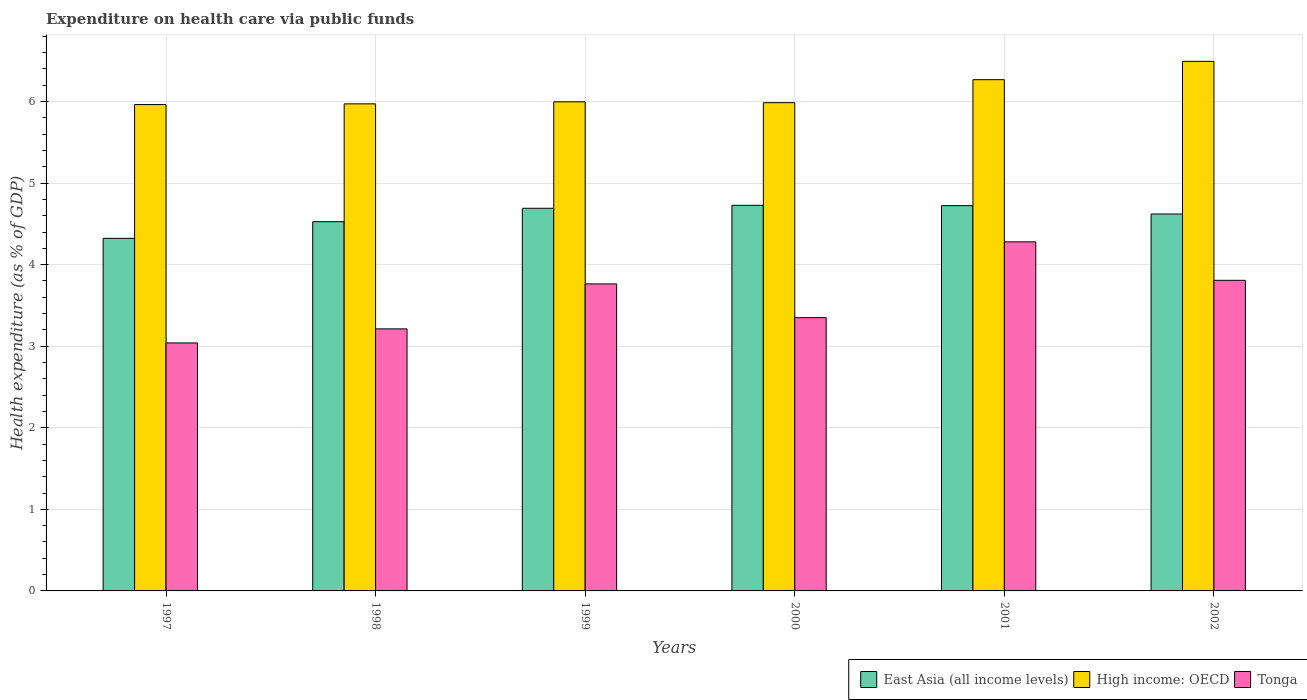How many different coloured bars are there?
Make the answer very short. 3. How many groups of bars are there?
Offer a terse response. 6. Are the number of bars per tick equal to the number of legend labels?
Your answer should be compact. Yes. How many bars are there on the 6th tick from the left?
Give a very brief answer. 3. What is the label of the 3rd group of bars from the left?
Provide a succinct answer. 1999. What is the expenditure made on health care in Tonga in 2000?
Offer a very short reply. 3.35. Across all years, what is the maximum expenditure made on health care in High income: OECD?
Offer a very short reply. 6.49. Across all years, what is the minimum expenditure made on health care in East Asia (all income levels)?
Make the answer very short. 4.32. In which year was the expenditure made on health care in Tonga minimum?
Your answer should be compact. 1997. What is the total expenditure made on health care in East Asia (all income levels) in the graph?
Your answer should be compact. 27.61. What is the difference between the expenditure made on health care in East Asia (all income levels) in 1999 and that in 2002?
Give a very brief answer. 0.07. What is the difference between the expenditure made on health care in Tonga in 2000 and the expenditure made on health care in East Asia (all income levels) in 1999?
Provide a succinct answer. -1.34. What is the average expenditure made on health care in Tonga per year?
Provide a short and direct response. 3.58. In the year 2001, what is the difference between the expenditure made on health care in High income: OECD and expenditure made on health care in East Asia (all income levels)?
Provide a succinct answer. 1.54. What is the ratio of the expenditure made on health care in Tonga in 2000 to that in 2002?
Provide a succinct answer. 0.88. What is the difference between the highest and the second highest expenditure made on health care in East Asia (all income levels)?
Make the answer very short. 0. What is the difference between the highest and the lowest expenditure made on health care in East Asia (all income levels)?
Give a very brief answer. 0.4. In how many years, is the expenditure made on health care in East Asia (all income levels) greater than the average expenditure made on health care in East Asia (all income levels) taken over all years?
Provide a succinct answer. 4. Is the sum of the expenditure made on health care in High income: OECD in 1999 and 2001 greater than the maximum expenditure made on health care in Tonga across all years?
Your answer should be very brief. Yes. What does the 2nd bar from the left in 1999 represents?
Provide a short and direct response. High income: OECD. What does the 2nd bar from the right in 2002 represents?
Offer a terse response. High income: OECD. Is it the case that in every year, the sum of the expenditure made on health care in Tonga and expenditure made on health care in High income: OECD is greater than the expenditure made on health care in East Asia (all income levels)?
Your answer should be compact. Yes. Does the graph contain any zero values?
Offer a very short reply. No. Does the graph contain grids?
Your response must be concise. Yes. Where does the legend appear in the graph?
Ensure brevity in your answer.  Bottom right. How many legend labels are there?
Offer a very short reply. 3. How are the legend labels stacked?
Your response must be concise. Horizontal. What is the title of the graph?
Your answer should be compact. Expenditure on health care via public funds. What is the label or title of the Y-axis?
Your answer should be compact. Health expenditure (as % of GDP). What is the Health expenditure (as % of GDP) of East Asia (all income levels) in 1997?
Your response must be concise. 4.32. What is the Health expenditure (as % of GDP) of High income: OECD in 1997?
Make the answer very short. 5.96. What is the Health expenditure (as % of GDP) of Tonga in 1997?
Ensure brevity in your answer.  3.04. What is the Health expenditure (as % of GDP) in East Asia (all income levels) in 1998?
Offer a terse response. 4.53. What is the Health expenditure (as % of GDP) in High income: OECD in 1998?
Give a very brief answer. 5.97. What is the Health expenditure (as % of GDP) of Tonga in 1998?
Ensure brevity in your answer.  3.21. What is the Health expenditure (as % of GDP) of East Asia (all income levels) in 1999?
Your answer should be compact. 4.69. What is the Health expenditure (as % of GDP) in High income: OECD in 1999?
Your response must be concise. 6. What is the Health expenditure (as % of GDP) of Tonga in 1999?
Offer a very short reply. 3.76. What is the Health expenditure (as % of GDP) of East Asia (all income levels) in 2000?
Offer a terse response. 4.73. What is the Health expenditure (as % of GDP) of High income: OECD in 2000?
Keep it short and to the point. 5.99. What is the Health expenditure (as % of GDP) of Tonga in 2000?
Keep it short and to the point. 3.35. What is the Health expenditure (as % of GDP) in East Asia (all income levels) in 2001?
Keep it short and to the point. 4.72. What is the Health expenditure (as % of GDP) of High income: OECD in 2001?
Your answer should be very brief. 6.27. What is the Health expenditure (as % of GDP) of Tonga in 2001?
Your response must be concise. 4.28. What is the Health expenditure (as % of GDP) of East Asia (all income levels) in 2002?
Keep it short and to the point. 4.62. What is the Health expenditure (as % of GDP) of High income: OECD in 2002?
Provide a succinct answer. 6.49. What is the Health expenditure (as % of GDP) in Tonga in 2002?
Keep it short and to the point. 3.81. Across all years, what is the maximum Health expenditure (as % of GDP) of East Asia (all income levels)?
Offer a very short reply. 4.73. Across all years, what is the maximum Health expenditure (as % of GDP) of High income: OECD?
Provide a short and direct response. 6.49. Across all years, what is the maximum Health expenditure (as % of GDP) of Tonga?
Offer a terse response. 4.28. Across all years, what is the minimum Health expenditure (as % of GDP) in East Asia (all income levels)?
Make the answer very short. 4.32. Across all years, what is the minimum Health expenditure (as % of GDP) in High income: OECD?
Your response must be concise. 5.96. Across all years, what is the minimum Health expenditure (as % of GDP) in Tonga?
Keep it short and to the point. 3.04. What is the total Health expenditure (as % of GDP) in East Asia (all income levels) in the graph?
Your answer should be very brief. 27.61. What is the total Health expenditure (as % of GDP) in High income: OECD in the graph?
Provide a short and direct response. 36.68. What is the total Health expenditure (as % of GDP) in Tonga in the graph?
Make the answer very short. 21.45. What is the difference between the Health expenditure (as % of GDP) of East Asia (all income levels) in 1997 and that in 1998?
Make the answer very short. -0.2. What is the difference between the Health expenditure (as % of GDP) of High income: OECD in 1997 and that in 1998?
Make the answer very short. -0.01. What is the difference between the Health expenditure (as % of GDP) of Tonga in 1997 and that in 1998?
Make the answer very short. -0.17. What is the difference between the Health expenditure (as % of GDP) of East Asia (all income levels) in 1997 and that in 1999?
Keep it short and to the point. -0.37. What is the difference between the Health expenditure (as % of GDP) in High income: OECD in 1997 and that in 1999?
Your response must be concise. -0.03. What is the difference between the Health expenditure (as % of GDP) in Tonga in 1997 and that in 1999?
Provide a succinct answer. -0.72. What is the difference between the Health expenditure (as % of GDP) in East Asia (all income levels) in 1997 and that in 2000?
Your response must be concise. -0.4. What is the difference between the Health expenditure (as % of GDP) of High income: OECD in 1997 and that in 2000?
Your answer should be very brief. -0.02. What is the difference between the Health expenditure (as % of GDP) of Tonga in 1997 and that in 2000?
Give a very brief answer. -0.31. What is the difference between the Health expenditure (as % of GDP) of East Asia (all income levels) in 1997 and that in 2001?
Your response must be concise. -0.4. What is the difference between the Health expenditure (as % of GDP) in High income: OECD in 1997 and that in 2001?
Give a very brief answer. -0.3. What is the difference between the Health expenditure (as % of GDP) in Tonga in 1997 and that in 2001?
Your answer should be very brief. -1.24. What is the difference between the Health expenditure (as % of GDP) of East Asia (all income levels) in 1997 and that in 2002?
Give a very brief answer. -0.3. What is the difference between the Health expenditure (as % of GDP) of High income: OECD in 1997 and that in 2002?
Your response must be concise. -0.53. What is the difference between the Health expenditure (as % of GDP) of Tonga in 1997 and that in 2002?
Provide a short and direct response. -0.77. What is the difference between the Health expenditure (as % of GDP) in East Asia (all income levels) in 1998 and that in 1999?
Offer a very short reply. -0.16. What is the difference between the Health expenditure (as % of GDP) in High income: OECD in 1998 and that in 1999?
Your answer should be compact. -0.02. What is the difference between the Health expenditure (as % of GDP) of Tonga in 1998 and that in 1999?
Your answer should be compact. -0.55. What is the difference between the Health expenditure (as % of GDP) of East Asia (all income levels) in 1998 and that in 2000?
Your answer should be very brief. -0.2. What is the difference between the Health expenditure (as % of GDP) of High income: OECD in 1998 and that in 2000?
Keep it short and to the point. -0.01. What is the difference between the Health expenditure (as % of GDP) in Tonga in 1998 and that in 2000?
Your answer should be very brief. -0.14. What is the difference between the Health expenditure (as % of GDP) of East Asia (all income levels) in 1998 and that in 2001?
Offer a terse response. -0.2. What is the difference between the Health expenditure (as % of GDP) of High income: OECD in 1998 and that in 2001?
Offer a very short reply. -0.3. What is the difference between the Health expenditure (as % of GDP) of Tonga in 1998 and that in 2001?
Provide a succinct answer. -1.07. What is the difference between the Health expenditure (as % of GDP) of East Asia (all income levels) in 1998 and that in 2002?
Make the answer very short. -0.09. What is the difference between the Health expenditure (as % of GDP) in High income: OECD in 1998 and that in 2002?
Offer a terse response. -0.52. What is the difference between the Health expenditure (as % of GDP) of Tonga in 1998 and that in 2002?
Keep it short and to the point. -0.6. What is the difference between the Health expenditure (as % of GDP) in East Asia (all income levels) in 1999 and that in 2000?
Provide a short and direct response. -0.04. What is the difference between the Health expenditure (as % of GDP) of High income: OECD in 1999 and that in 2000?
Provide a short and direct response. 0.01. What is the difference between the Health expenditure (as % of GDP) in Tonga in 1999 and that in 2000?
Make the answer very short. 0.41. What is the difference between the Health expenditure (as % of GDP) in East Asia (all income levels) in 1999 and that in 2001?
Your answer should be compact. -0.03. What is the difference between the Health expenditure (as % of GDP) in High income: OECD in 1999 and that in 2001?
Offer a very short reply. -0.27. What is the difference between the Health expenditure (as % of GDP) in Tonga in 1999 and that in 2001?
Ensure brevity in your answer.  -0.52. What is the difference between the Health expenditure (as % of GDP) in East Asia (all income levels) in 1999 and that in 2002?
Your answer should be very brief. 0.07. What is the difference between the Health expenditure (as % of GDP) of High income: OECD in 1999 and that in 2002?
Your answer should be very brief. -0.5. What is the difference between the Health expenditure (as % of GDP) in Tonga in 1999 and that in 2002?
Your response must be concise. -0.04. What is the difference between the Health expenditure (as % of GDP) of East Asia (all income levels) in 2000 and that in 2001?
Your answer should be very brief. 0. What is the difference between the Health expenditure (as % of GDP) of High income: OECD in 2000 and that in 2001?
Provide a succinct answer. -0.28. What is the difference between the Health expenditure (as % of GDP) in Tonga in 2000 and that in 2001?
Your answer should be compact. -0.93. What is the difference between the Health expenditure (as % of GDP) of East Asia (all income levels) in 2000 and that in 2002?
Your answer should be compact. 0.11. What is the difference between the Health expenditure (as % of GDP) in High income: OECD in 2000 and that in 2002?
Provide a succinct answer. -0.51. What is the difference between the Health expenditure (as % of GDP) in Tonga in 2000 and that in 2002?
Your response must be concise. -0.46. What is the difference between the Health expenditure (as % of GDP) in East Asia (all income levels) in 2001 and that in 2002?
Ensure brevity in your answer.  0.1. What is the difference between the Health expenditure (as % of GDP) of High income: OECD in 2001 and that in 2002?
Your answer should be very brief. -0.22. What is the difference between the Health expenditure (as % of GDP) in Tonga in 2001 and that in 2002?
Your answer should be compact. 0.47. What is the difference between the Health expenditure (as % of GDP) of East Asia (all income levels) in 1997 and the Health expenditure (as % of GDP) of High income: OECD in 1998?
Offer a very short reply. -1.65. What is the difference between the Health expenditure (as % of GDP) in East Asia (all income levels) in 1997 and the Health expenditure (as % of GDP) in Tonga in 1998?
Your response must be concise. 1.11. What is the difference between the Health expenditure (as % of GDP) in High income: OECD in 1997 and the Health expenditure (as % of GDP) in Tonga in 1998?
Make the answer very short. 2.75. What is the difference between the Health expenditure (as % of GDP) of East Asia (all income levels) in 1997 and the Health expenditure (as % of GDP) of High income: OECD in 1999?
Keep it short and to the point. -1.67. What is the difference between the Health expenditure (as % of GDP) in East Asia (all income levels) in 1997 and the Health expenditure (as % of GDP) in Tonga in 1999?
Keep it short and to the point. 0.56. What is the difference between the Health expenditure (as % of GDP) of High income: OECD in 1997 and the Health expenditure (as % of GDP) of Tonga in 1999?
Provide a short and direct response. 2.2. What is the difference between the Health expenditure (as % of GDP) of East Asia (all income levels) in 1997 and the Health expenditure (as % of GDP) of High income: OECD in 2000?
Your answer should be compact. -1.66. What is the difference between the Health expenditure (as % of GDP) in East Asia (all income levels) in 1997 and the Health expenditure (as % of GDP) in Tonga in 2000?
Offer a very short reply. 0.97. What is the difference between the Health expenditure (as % of GDP) of High income: OECD in 1997 and the Health expenditure (as % of GDP) of Tonga in 2000?
Provide a short and direct response. 2.61. What is the difference between the Health expenditure (as % of GDP) of East Asia (all income levels) in 1997 and the Health expenditure (as % of GDP) of High income: OECD in 2001?
Keep it short and to the point. -1.95. What is the difference between the Health expenditure (as % of GDP) in East Asia (all income levels) in 1997 and the Health expenditure (as % of GDP) in Tonga in 2001?
Provide a succinct answer. 0.04. What is the difference between the Health expenditure (as % of GDP) of High income: OECD in 1997 and the Health expenditure (as % of GDP) of Tonga in 2001?
Ensure brevity in your answer.  1.68. What is the difference between the Health expenditure (as % of GDP) of East Asia (all income levels) in 1997 and the Health expenditure (as % of GDP) of High income: OECD in 2002?
Your answer should be compact. -2.17. What is the difference between the Health expenditure (as % of GDP) in East Asia (all income levels) in 1997 and the Health expenditure (as % of GDP) in Tonga in 2002?
Ensure brevity in your answer.  0.51. What is the difference between the Health expenditure (as % of GDP) of High income: OECD in 1997 and the Health expenditure (as % of GDP) of Tonga in 2002?
Your response must be concise. 2.15. What is the difference between the Health expenditure (as % of GDP) in East Asia (all income levels) in 1998 and the Health expenditure (as % of GDP) in High income: OECD in 1999?
Provide a succinct answer. -1.47. What is the difference between the Health expenditure (as % of GDP) in East Asia (all income levels) in 1998 and the Health expenditure (as % of GDP) in Tonga in 1999?
Your response must be concise. 0.76. What is the difference between the Health expenditure (as % of GDP) in High income: OECD in 1998 and the Health expenditure (as % of GDP) in Tonga in 1999?
Your answer should be very brief. 2.21. What is the difference between the Health expenditure (as % of GDP) in East Asia (all income levels) in 1998 and the Health expenditure (as % of GDP) in High income: OECD in 2000?
Offer a very short reply. -1.46. What is the difference between the Health expenditure (as % of GDP) of East Asia (all income levels) in 1998 and the Health expenditure (as % of GDP) of Tonga in 2000?
Provide a succinct answer. 1.18. What is the difference between the Health expenditure (as % of GDP) in High income: OECD in 1998 and the Health expenditure (as % of GDP) in Tonga in 2000?
Give a very brief answer. 2.62. What is the difference between the Health expenditure (as % of GDP) of East Asia (all income levels) in 1998 and the Health expenditure (as % of GDP) of High income: OECD in 2001?
Offer a very short reply. -1.74. What is the difference between the Health expenditure (as % of GDP) in East Asia (all income levels) in 1998 and the Health expenditure (as % of GDP) in Tonga in 2001?
Give a very brief answer. 0.25. What is the difference between the Health expenditure (as % of GDP) of High income: OECD in 1998 and the Health expenditure (as % of GDP) of Tonga in 2001?
Your answer should be very brief. 1.69. What is the difference between the Health expenditure (as % of GDP) of East Asia (all income levels) in 1998 and the Health expenditure (as % of GDP) of High income: OECD in 2002?
Ensure brevity in your answer.  -1.97. What is the difference between the Health expenditure (as % of GDP) of East Asia (all income levels) in 1998 and the Health expenditure (as % of GDP) of Tonga in 2002?
Offer a very short reply. 0.72. What is the difference between the Health expenditure (as % of GDP) of High income: OECD in 1998 and the Health expenditure (as % of GDP) of Tonga in 2002?
Ensure brevity in your answer.  2.16. What is the difference between the Health expenditure (as % of GDP) of East Asia (all income levels) in 1999 and the Health expenditure (as % of GDP) of High income: OECD in 2000?
Make the answer very short. -1.29. What is the difference between the Health expenditure (as % of GDP) in East Asia (all income levels) in 1999 and the Health expenditure (as % of GDP) in Tonga in 2000?
Give a very brief answer. 1.34. What is the difference between the Health expenditure (as % of GDP) in High income: OECD in 1999 and the Health expenditure (as % of GDP) in Tonga in 2000?
Provide a short and direct response. 2.65. What is the difference between the Health expenditure (as % of GDP) in East Asia (all income levels) in 1999 and the Health expenditure (as % of GDP) in High income: OECD in 2001?
Provide a short and direct response. -1.58. What is the difference between the Health expenditure (as % of GDP) in East Asia (all income levels) in 1999 and the Health expenditure (as % of GDP) in Tonga in 2001?
Provide a succinct answer. 0.41. What is the difference between the Health expenditure (as % of GDP) of High income: OECD in 1999 and the Health expenditure (as % of GDP) of Tonga in 2001?
Provide a short and direct response. 1.72. What is the difference between the Health expenditure (as % of GDP) of East Asia (all income levels) in 1999 and the Health expenditure (as % of GDP) of High income: OECD in 2002?
Your answer should be very brief. -1.8. What is the difference between the Health expenditure (as % of GDP) of East Asia (all income levels) in 1999 and the Health expenditure (as % of GDP) of Tonga in 2002?
Make the answer very short. 0.88. What is the difference between the Health expenditure (as % of GDP) of High income: OECD in 1999 and the Health expenditure (as % of GDP) of Tonga in 2002?
Ensure brevity in your answer.  2.19. What is the difference between the Health expenditure (as % of GDP) of East Asia (all income levels) in 2000 and the Health expenditure (as % of GDP) of High income: OECD in 2001?
Provide a short and direct response. -1.54. What is the difference between the Health expenditure (as % of GDP) in East Asia (all income levels) in 2000 and the Health expenditure (as % of GDP) in Tonga in 2001?
Ensure brevity in your answer.  0.45. What is the difference between the Health expenditure (as % of GDP) of High income: OECD in 2000 and the Health expenditure (as % of GDP) of Tonga in 2001?
Ensure brevity in your answer.  1.71. What is the difference between the Health expenditure (as % of GDP) of East Asia (all income levels) in 2000 and the Health expenditure (as % of GDP) of High income: OECD in 2002?
Make the answer very short. -1.76. What is the difference between the Health expenditure (as % of GDP) in East Asia (all income levels) in 2000 and the Health expenditure (as % of GDP) in Tonga in 2002?
Your answer should be very brief. 0.92. What is the difference between the Health expenditure (as % of GDP) in High income: OECD in 2000 and the Health expenditure (as % of GDP) in Tonga in 2002?
Offer a terse response. 2.18. What is the difference between the Health expenditure (as % of GDP) in East Asia (all income levels) in 2001 and the Health expenditure (as % of GDP) in High income: OECD in 2002?
Ensure brevity in your answer.  -1.77. What is the difference between the Health expenditure (as % of GDP) in East Asia (all income levels) in 2001 and the Health expenditure (as % of GDP) in Tonga in 2002?
Provide a short and direct response. 0.92. What is the difference between the Health expenditure (as % of GDP) of High income: OECD in 2001 and the Health expenditure (as % of GDP) of Tonga in 2002?
Give a very brief answer. 2.46. What is the average Health expenditure (as % of GDP) in East Asia (all income levels) per year?
Provide a succinct answer. 4.6. What is the average Health expenditure (as % of GDP) in High income: OECD per year?
Ensure brevity in your answer.  6.11. What is the average Health expenditure (as % of GDP) in Tonga per year?
Make the answer very short. 3.58. In the year 1997, what is the difference between the Health expenditure (as % of GDP) in East Asia (all income levels) and Health expenditure (as % of GDP) in High income: OECD?
Make the answer very short. -1.64. In the year 1997, what is the difference between the Health expenditure (as % of GDP) of East Asia (all income levels) and Health expenditure (as % of GDP) of Tonga?
Provide a succinct answer. 1.28. In the year 1997, what is the difference between the Health expenditure (as % of GDP) of High income: OECD and Health expenditure (as % of GDP) of Tonga?
Provide a succinct answer. 2.92. In the year 1998, what is the difference between the Health expenditure (as % of GDP) in East Asia (all income levels) and Health expenditure (as % of GDP) in High income: OECD?
Ensure brevity in your answer.  -1.44. In the year 1998, what is the difference between the Health expenditure (as % of GDP) in East Asia (all income levels) and Health expenditure (as % of GDP) in Tonga?
Your answer should be compact. 1.31. In the year 1998, what is the difference between the Health expenditure (as % of GDP) of High income: OECD and Health expenditure (as % of GDP) of Tonga?
Give a very brief answer. 2.76. In the year 1999, what is the difference between the Health expenditure (as % of GDP) in East Asia (all income levels) and Health expenditure (as % of GDP) in High income: OECD?
Offer a very short reply. -1.31. In the year 1999, what is the difference between the Health expenditure (as % of GDP) of East Asia (all income levels) and Health expenditure (as % of GDP) of Tonga?
Ensure brevity in your answer.  0.93. In the year 1999, what is the difference between the Health expenditure (as % of GDP) of High income: OECD and Health expenditure (as % of GDP) of Tonga?
Ensure brevity in your answer.  2.23. In the year 2000, what is the difference between the Health expenditure (as % of GDP) of East Asia (all income levels) and Health expenditure (as % of GDP) of High income: OECD?
Offer a terse response. -1.26. In the year 2000, what is the difference between the Health expenditure (as % of GDP) in East Asia (all income levels) and Health expenditure (as % of GDP) in Tonga?
Your answer should be compact. 1.38. In the year 2000, what is the difference between the Health expenditure (as % of GDP) of High income: OECD and Health expenditure (as % of GDP) of Tonga?
Offer a very short reply. 2.64. In the year 2001, what is the difference between the Health expenditure (as % of GDP) of East Asia (all income levels) and Health expenditure (as % of GDP) of High income: OECD?
Offer a very short reply. -1.54. In the year 2001, what is the difference between the Health expenditure (as % of GDP) of East Asia (all income levels) and Health expenditure (as % of GDP) of Tonga?
Your answer should be compact. 0.44. In the year 2001, what is the difference between the Health expenditure (as % of GDP) in High income: OECD and Health expenditure (as % of GDP) in Tonga?
Your response must be concise. 1.99. In the year 2002, what is the difference between the Health expenditure (as % of GDP) of East Asia (all income levels) and Health expenditure (as % of GDP) of High income: OECD?
Provide a succinct answer. -1.87. In the year 2002, what is the difference between the Health expenditure (as % of GDP) of East Asia (all income levels) and Health expenditure (as % of GDP) of Tonga?
Make the answer very short. 0.81. In the year 2002, what is the difference between the Health expenditure (as % of GDP) in High income: OECD and Health expenditure (as % of GDP) in Tonga?
Your response must be concise. 2.68. What is the ratio of the Health expenditure (as % of GDP) in East Asia (all income levels) in 1997 to that in 1998?
Offer a very short reply. 0.95. What is the ratio of the Health expenditure (as % of GDP) in High income: OECD in 1997 to that in 1998?
Offer a terse response. 1. What is the ratio of the Health expenditure (as % of GDP) in Tonga in 1997 to that in 1998?
Your answer should be very brief. 0.95. What is the ratio of the Health expenditure (as % of GDP) in East Asia (all income levels) in 1997 to that in 1999?
Give a very brief answer. 0.92. What is the ratio of the Health expenditure (as % of GDP) in High income: OECD in 1997 to that in 1999?
Provide a short and direct response. 0.99. What is the ratio of the Health expenditure (as % of GDP) in Tonga in 1997 to that in 1999?
Your answer should be very brief. 0.81. What is the ratio of the Health expenditure (as % of GDP) of East Asia (all income levels) in 1997 to that in 2000?
Your response must be concise. 0.91. What is the ratio of the Health expenditure (as % of GDP) of Tonga in 1997 to that in 2000?
Offer a very short reply. 0.91. What is the ratio of the Health expenditure (as % of GDP) of East Asia (all income levels) in 1997 to that in 2001?
Provide a short and direct response. 0.92. What is the ratio of the Health expenditure (as % of GDP) in High income: OECD in 1997 to that in 2001?
Your answer should be compact. 0.95. What is the ratio of the Health expenditure (as % of GDP) in Tonga in 1997 to that in 2001?
Your answer should be very brief. 0.71. What is the ratio of the Health expenditure (as % of GDP) of East Asia (all income levels) in 1997 to that in 2002?
Provide a succinct answer. 0.94. What is the ratio of the Health expenditure (as % of GDP) of High income: OECD in 1997 to that in 2002?
Your response must be concise. 0.92. What is the ratio of the Health expenditure (as % of GDP) of Tonga in 1997 to that in 2002?
Your response must be concise. 0.8. What is the ratio of the Health expenditure (as % of GDP) in East Asia (all income levels) in 1998 to that in 1999?
Your answer should be very brief. 0.96. What is the ratio of the Health expenditure (as % of GDP) in Tonga in 1998 to that in 1999?
Offer a very short reply. 0.85. What is the ratio of the Health expenditure (as % of GDP) in East Asia (all income levels) in 1998 to that in 2000?
Your answer should be very brief. 0.96. What is the ratio of the Health expenditure (as % of GDP) of High income: OECD in 1998 to that in 2000?
Your answer should be compact. 1. What is the ratio of the Health expenditure (as % of GDP) in Tonga in 1998 to that in 2000?
Provide a short and direct response. 0.96. What is the ratio of the Health expenditure (as % of GDP) in East Asia (all income levels) in 1998 to that in 2001?
Your response must be concise. 0.96. What is the ratio of the Health expenditure (as % of GDP) of High income: OECD in 1998 to that in 2001?
Provide a short and direct response. 0.95. What is the ratio of the Health expenditure (as % of GDP) of Tonga in 1998 to that in 2001?
Offer a very short reply. 0.75. What is the ratio of the Health expenditure (as % of GDP) in East Asia (all income levels) in 1998 to that in 2002?
Offer a very short reply. 0.98. What is the ratio of the Health expenditure (as % of GDP) of High income: OECD in 1998 to that in 2002?
Your response must be concise. 0.92. What is the ratio of the Health expenditure (as % of GDP) in Tonga in 1998 to that in 2002?
Make the answer very short. 0.84. What is the ratio of the Health expenditure (as % of GDP) of East Asia (all income levels) in 1999 to that in 2000?
Give a very brief answer. 0.99. What is the ratio of the Health expenditure (as % of GDP) of High income: OECD in 1999 to that in 2000?
Your response must be concise. 1. What is the ratio of the Health expenditure (as % of GDP) of Tonga in 1999 to that in 2000?
Give a very brief answer. 1.12. What is the ratio of the Health expenditure (as % of GDP) in High income: OECD in 1999 to that in 2001?
Keep it short and to the point. 0.96. What is the ratio of the Health expenditure (as % of GDP) of Tonga in 1999 to that in 2001?
Keep it short and to the point. 0.88. What is the ratio of the Health expenditure (as % of GDP) of East Asia (all income levels) in 1999 to that in 2002?
Provide a succinct answer. 1.02. What is the ratio of the Health expenditure (as % of GDP) of High income: OECD in 1999 to that in 2002?
Offer a very short reply. 0.92. What is the ratio of the Health expenditure (as % of GDP) in Tonga in 1999 to that in 2002?
Ensure brevity in your answer.  0.99. What is the ratio of the Health expenditure (as % of GDP) in East Asia (all income levels) in 2000 to that in 2001?
Your answer should be very brief. 1. What is the ratio of the Health expenditure (as % of GDP) of High income: OECD in 2000 to that in 2001?
Offer a very short reply. 0.95. What is the ratio of the Health expenditure (as % of GDP) of Tonga in 2000 to that in 2001?
Make the answer very short. 0.78. What is the ratio of the Health expenditure (as % of GDP) of East Asia (all income levels) in 2000 to that in 2002?
Your answer should be very brief. 1.02. What is the ratio of the Health expenditure (as % of GDP) of High income: OECD in 2000 to that in 2002?
Keep it short and to the point. 0.92. What is the ratio of the Health expenditure (as % of GDP) in Tonga in 2000 to that in 2002?
Keep it short and to the point. 0.88. What is the ratio of the Health expenditure (as % of GDP) of East Asia (all income levels) in 2001 to that in 2002?
Provide a short and direct response. 1.02. What is the ratio of the Health expenditure (as % of GDP) in High income: OECD in 2001 to that in 2002?
Your response must be concise. 0.97. What is the ratio of the Health expenditure (as % of GDP) of Tonga in 2001 to that in 2002?
Offer a very short reply. 1.12. What is the difference between the highest and the second highest Health expenditure (as % of GDP) in East Asia (all income levels)?
Offer a very short reply. 0. What is the difference between the highest and the second highest Health expenditure (as % of GDP) of High income: OECD?
Offer a very short reply. 0.22. What is the difference between the highest and the second highest Health expenditure (as % of GDP) of Tonga?
Your answer should be compact. 0.47. What is the difference between the highest and the lowest Health expenditure (as % of GDP) in East Asia (all income levels)?
Make the answer very short. 0.4. What is the difference between the highest and the lowest Health expenditure (as % of GDP) of High income: OECD?
Provide a short and direct response. 0.53. What is the difference between the highest and the lowest Health expenditure (as % of GDP) of Tonga?
Keep it short and to the point. 1.24. 